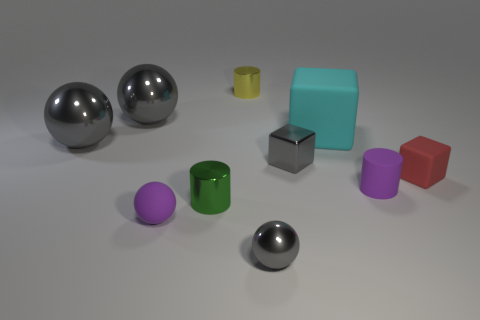Are there any other tiny objects that have the same shape as the tiny yellow object?
Your answer should be very brief. Yes. Are there fewer green cylinders behind the small green thing than cylinders that are behind the big cyan object?
Offer a terse response. Yes. The small metallic cube is what color?
Make the answer very short. Gray. There is a purple thing behind the green cylinder; are there any small matte balls that are behind it?
Keep it short and to the point. No. What number of yellow objects have the same size as the green thing?
Your answer should be very brief. 1. There is a metallic sphere right of the small metal cylinder that is in front of the tiny yellow cylinder; what number of tiny balls are behind it?
Your answer should be very brief. 1. What number of objects are in front of the gray shiny block and left of the tiny red matte thing?
Offer a terse response. 4. Are there any other things that have the same color as the small rubber cube?
Give a very brief answer. No. What number of metallic things are either blocks or cylinders?
Give a very brief answer. 3. What is the material of the tiny purple object that is to the left of the sphere that is in front of the purple rubber thing left of the cyan matte block?
Your answer should be very brief. Rubber. 